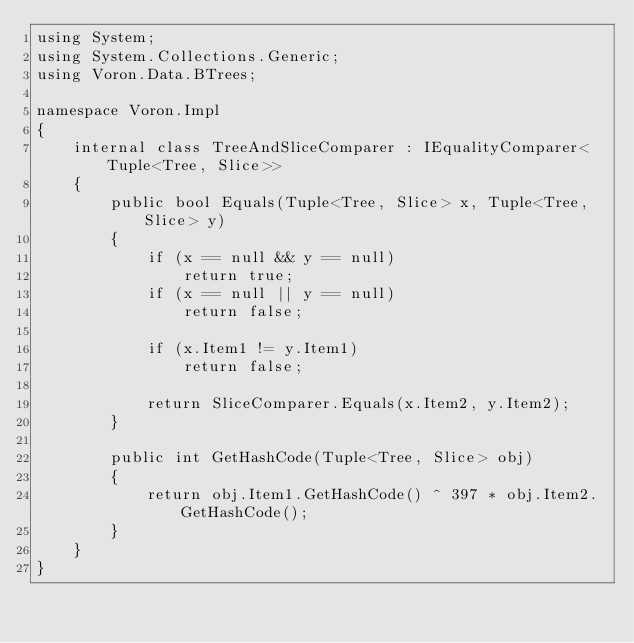<code> <loc_0><loc_0><loc_500><loc_500><_C#_>using System;
using System.Collections.Generic;
using Voron.Data.BTrees;

namespace Voron.Impl
{
    internal class TreeAndSliceComparer : IEqualityComparer<Tuple<Tree, Slice>>
    {
        public bool Equals(Tuple<Tree, Slice> x, Tuple<Tree, Slice> y)
        {
            if (x == null && y == null)
                return true;
            if (x == null || y == null)
                return false;

            if (x.Item1 != y.Item1)
                return false;

            return SliceComparer.Equals(x.Item2, y.Item2);
        }

        public int GetHashCode(Tuple<Tree, Slice> obj)
        {
            return obj.Item1.GetHashCode() ^ 397 * obj.Item2.GetHashCode();
        }
    }
}
</code> 